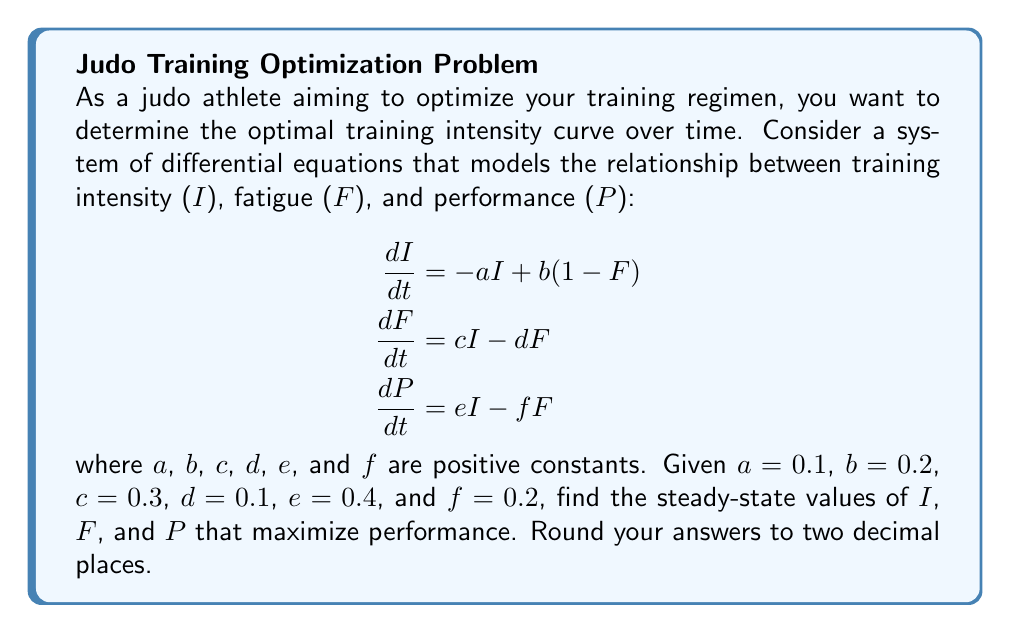Solve this math problem. To solve this problem, we'll follow these steps:

1) At steady-state, the derivatives are zero. So we set each equation to zero:

   $$\begin{aligned}
   0 &= -a I + b(1-F) \\
   0 &= c I - d F \\
   0 &= e I - f F
   \end{aligned}$$

2) From the second equation:
   $cI = dF$
   $F = \frac{c}{d}I$

3) Substitute this into the first equation:
   $0 = -aI + b(1-\frac{c}{d}I)$
   $0 = -aI + b - \frac{bc}{d}I$
   $0 = (-a - \frac{bc}{d})I + b$
   $I = \frac{b}{a + \frac{bc}{d}} = \frac{bd}{ad + bc}$

4) Now we can find F:
   $F = \frac{c}{d}I = \frac{c}{d} \cdot \frac{bd}{ad + bc} = \frac{bc}{ad + bc}$

5) And P:
   $P = \frac{e}{f}I = \frac{e}{f} \cdot \frac{bd}{ad + bc} = \frac{bde}{f(ad + bc)}$

6) Plugging in the given values:
   $I = \frac{0.2 \cdot 0.1}{0.1 \cdot 0.1 + 0.2 \cdot 0.3} = \frac{0.02}{0.07} \approx 0.29$

   $F = \frac{0.2 \cdot 0.3}{0.1 \cdot 0.1 + 0.2 \cdot 0.3} = \frac{0.06}{0.07} \approx 0.86$

   $P = \frac{0.2 \cdot 0.1 \cdot 0.4}{0.2(0.1 \cdot 0.1 + 0.2 \cdot 0.3)} = \frac{0.008}{0.014} \approx 0.57$

Therefore, the optimal steady-state values are $I \approx 0.29$, $F \approx 0.86$, and $P \approx 0.57$.
Answer: $I \approx 0.29$, $F \approx 0.86$, $P \approx 0.57$ 